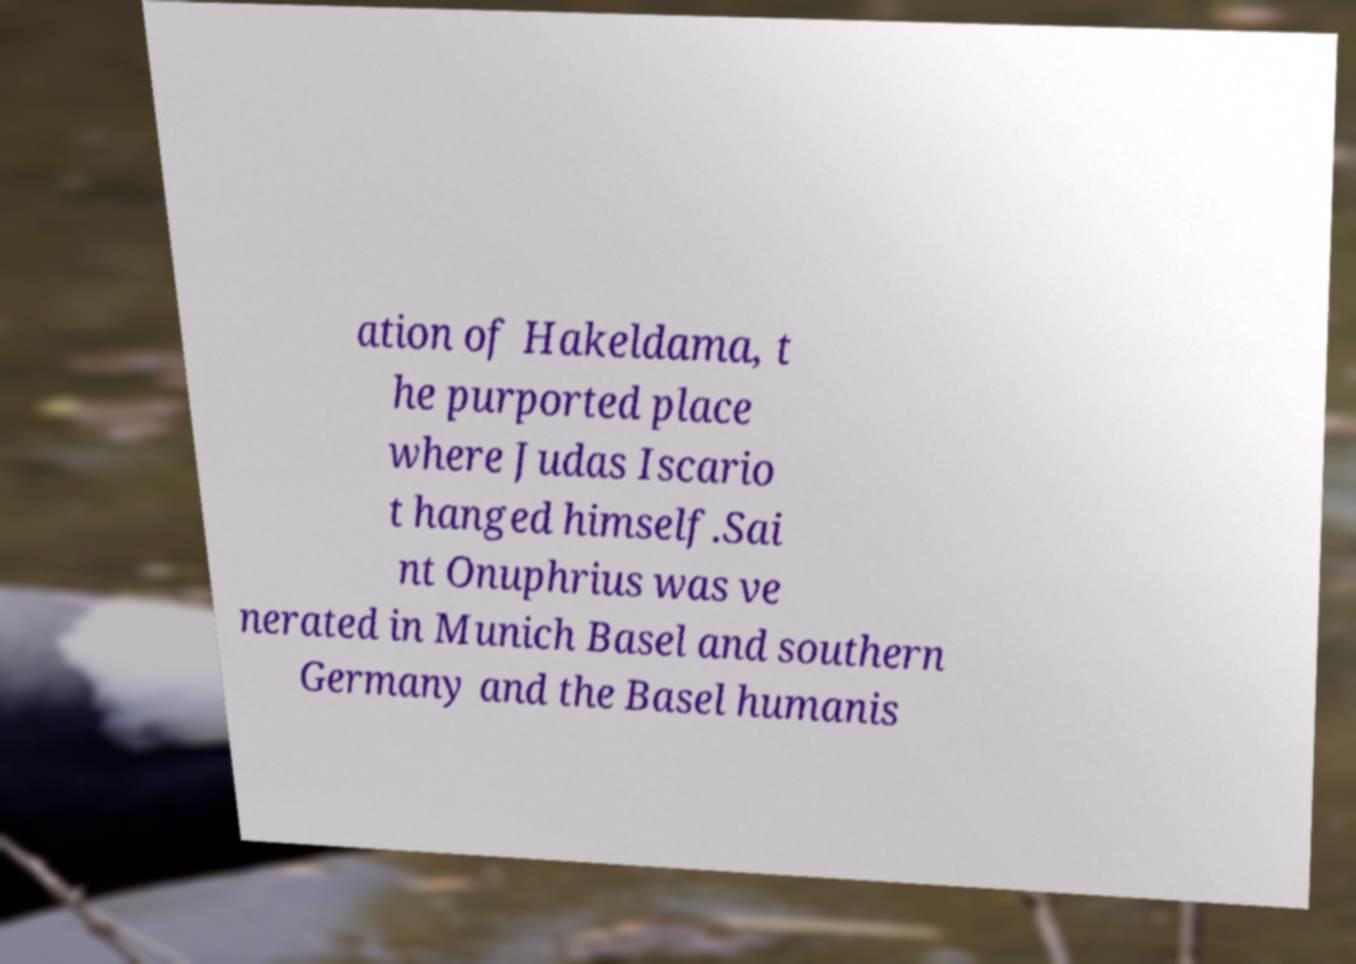For documentation purposes, I need the text within this image transcribed. Could you provide that? ation of Hakeldama, t he purported place where Judas Iscario t hanged himself.Sai nt Onuphrius was ve nerated in Munich Basel and southern Germany and the Basel humanis 